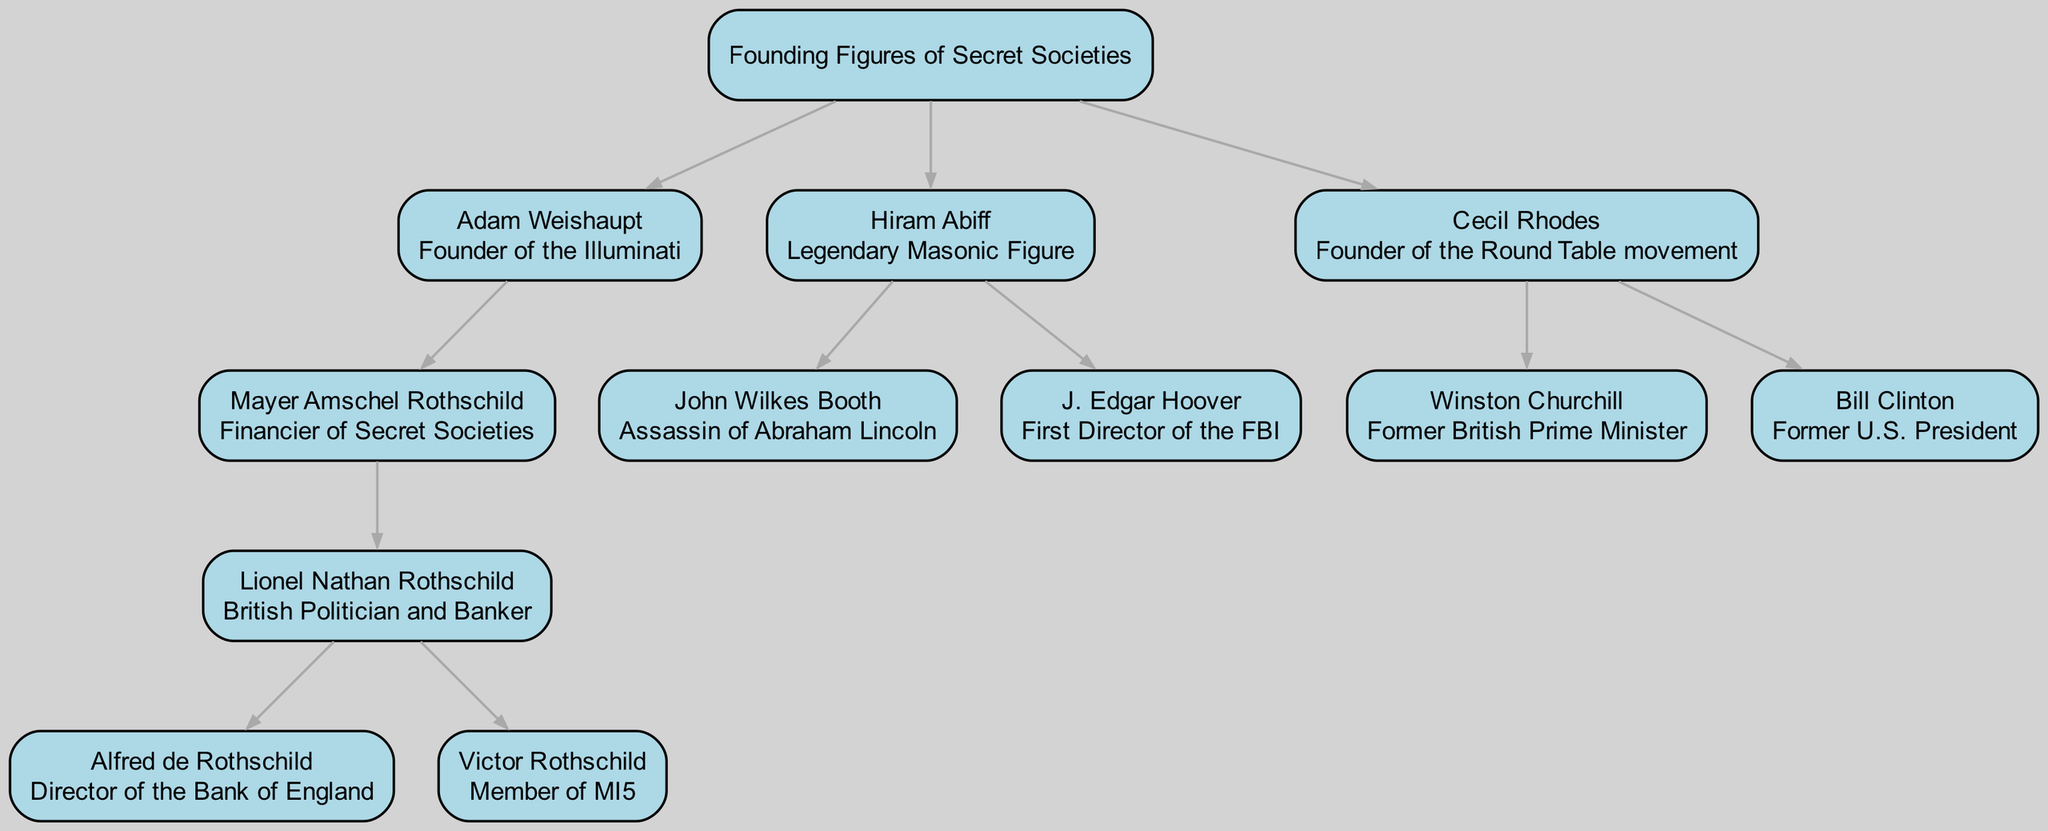What is the top node in the diagram? The top node in the diagram is labeled "Founding Figures of Secret Societies". It serves as the root node from which all other figures branch out.
Answer: Founding Figures of Secret Societies How many children does Adam Weishaupt have? Adam Weishaupt has one child in the diagram, which is Mayer Amschel Rothschild. This is determined by counting the nodes that directly branch from Adam Weishaupt.
Answer: 1 What is the relationship of John Wilkes Booth to Hiram Abiff? John Wilkes Booth is listed as a child of Hiram Abiff, indicating that he is a descendant or linked figure in relation to Hiram Abiff.
Answer: Assassin of Abraham Lincoln Who is the founder of the Round Table movement? The diagram indicates that Cecil Rhodes is the founder of the Round Table movement, which is directly stated next to his name.
Answer: Cecil Rhodes Name a child of Mayer Amschel Rothschild. The children of Mayer Amschel Rothschild include Lionel Nathan Rothschild, who is explicitly stated as his son in the diagram.
Answer: Lionel Nathan Rothschild Which major figure is associated with both the Illuminati and the Rothschilds? Adam Weishaupt is associated with the Illuminati as its founder, while Mayer Amschel Rothschild is linked to the Rothschilds; thus, they are both part of the same line in the diagram.
Answer: Adam Weishaupt How many major world leaders are linked to Cecil Rhodes? There are two major world leaders linked to Cecil Rhodes: Winston Churchill and Bill Clinton. This is counted by assessing the children under Cecil Rhodes in the diagram.
Answer: 2 Which individual has the relation of first director of the FBI? J. Edgar Hoover is noted in the diagram as the first director of the FBI, which is described under his relation.
Answer: J. Edgar Hoover Is there a direct connection between Victor Rothschild and Hiram Abiff? There is no direct connection indicated in the diagram between Victor Rothschild and Hiram Abiff, as they belong to separate branches of the family tree with no overlapping relationships.
Answer: No 